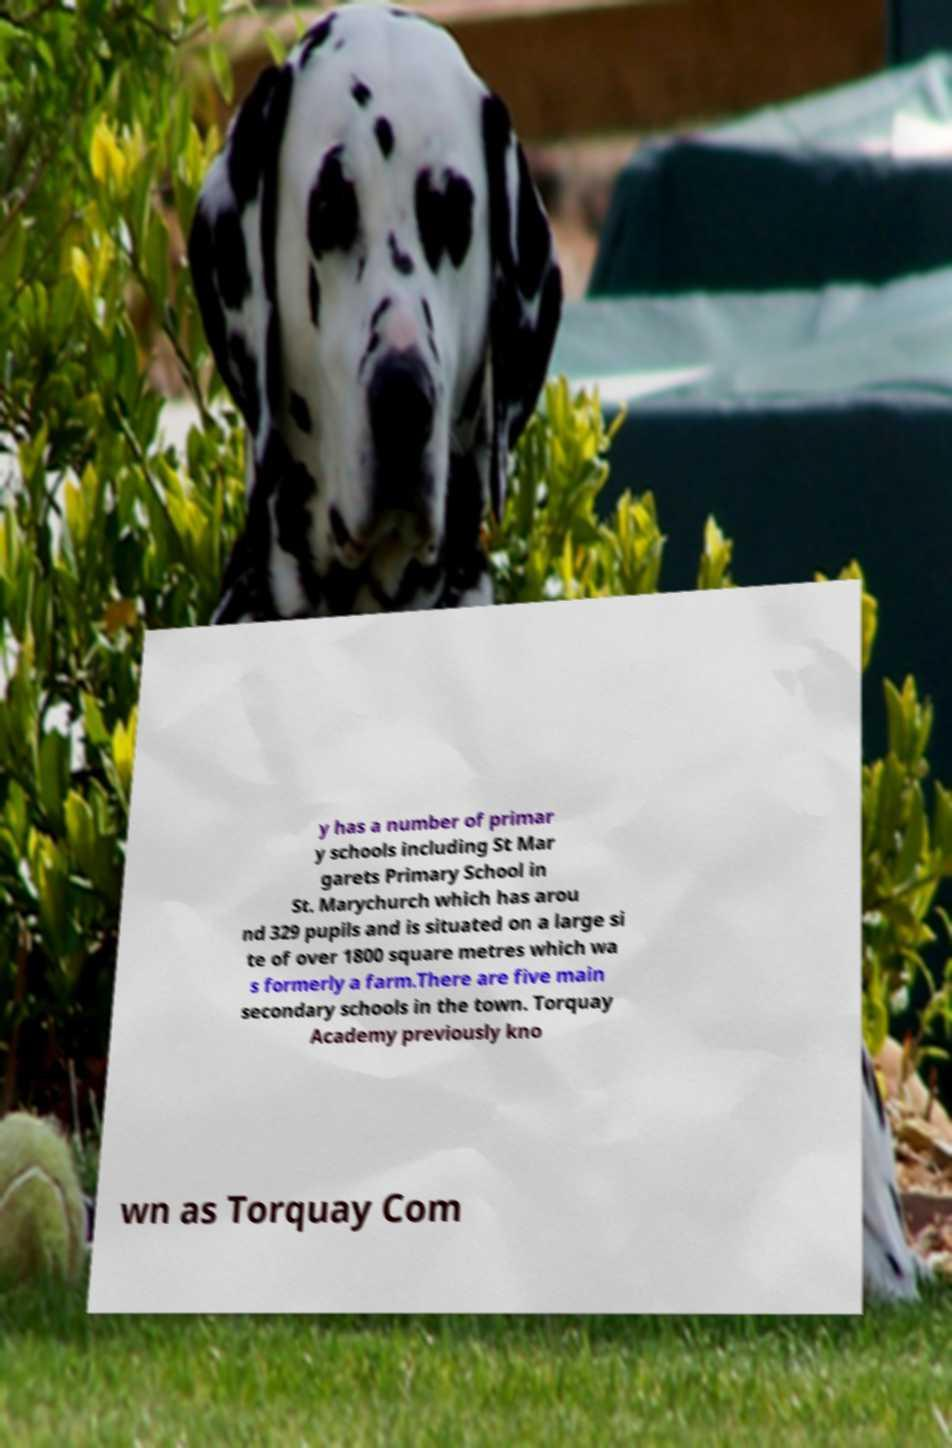Please read and relay the text visible in this image. What does it say? y has a number of primar y schools including St Mar garets Primary School in St. Marychurch which has arou nd 329 pupils and is situated on a large si te of over 1800 square metres which wa s formerly a farm.There are five main secondary schools in the town. Torquay Academy previously kno wn as Torquay Com 